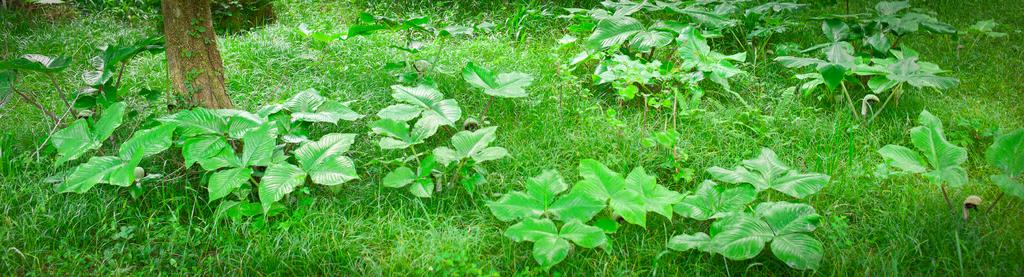What type of vegetation can be seen on the grassland in the image? There are many plants on the grassland in the image. Can you describe the tree in the image? There is a tree on the left side of the image. What type of support can be seen in the image? There is no support visible in the image; it features plants and a tree on a grassland. Can you describe the veins in the leaves of the plants in the image? There is no mention of veins in the leaves of the plants in the image, as the facts provided do not include this level of detail. 